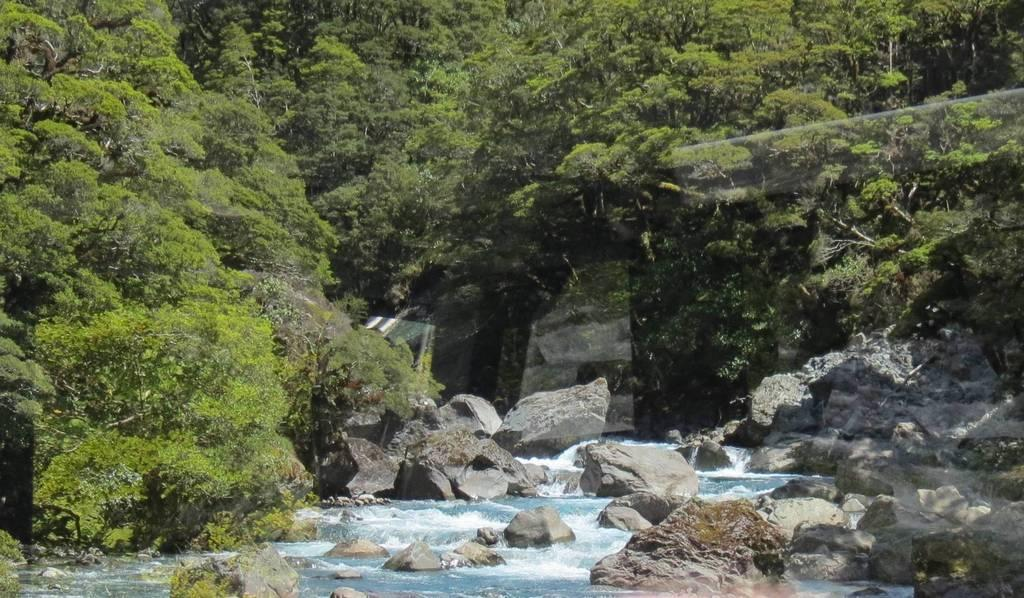What is the primary element visible in the image? There is water in the image. What other objects or features can be seen in the image? There are rocks and trees in the image. What type of advice can be seen written on the window in the image? There is no window present in the image, and therefore no advice can be seen written on it. 